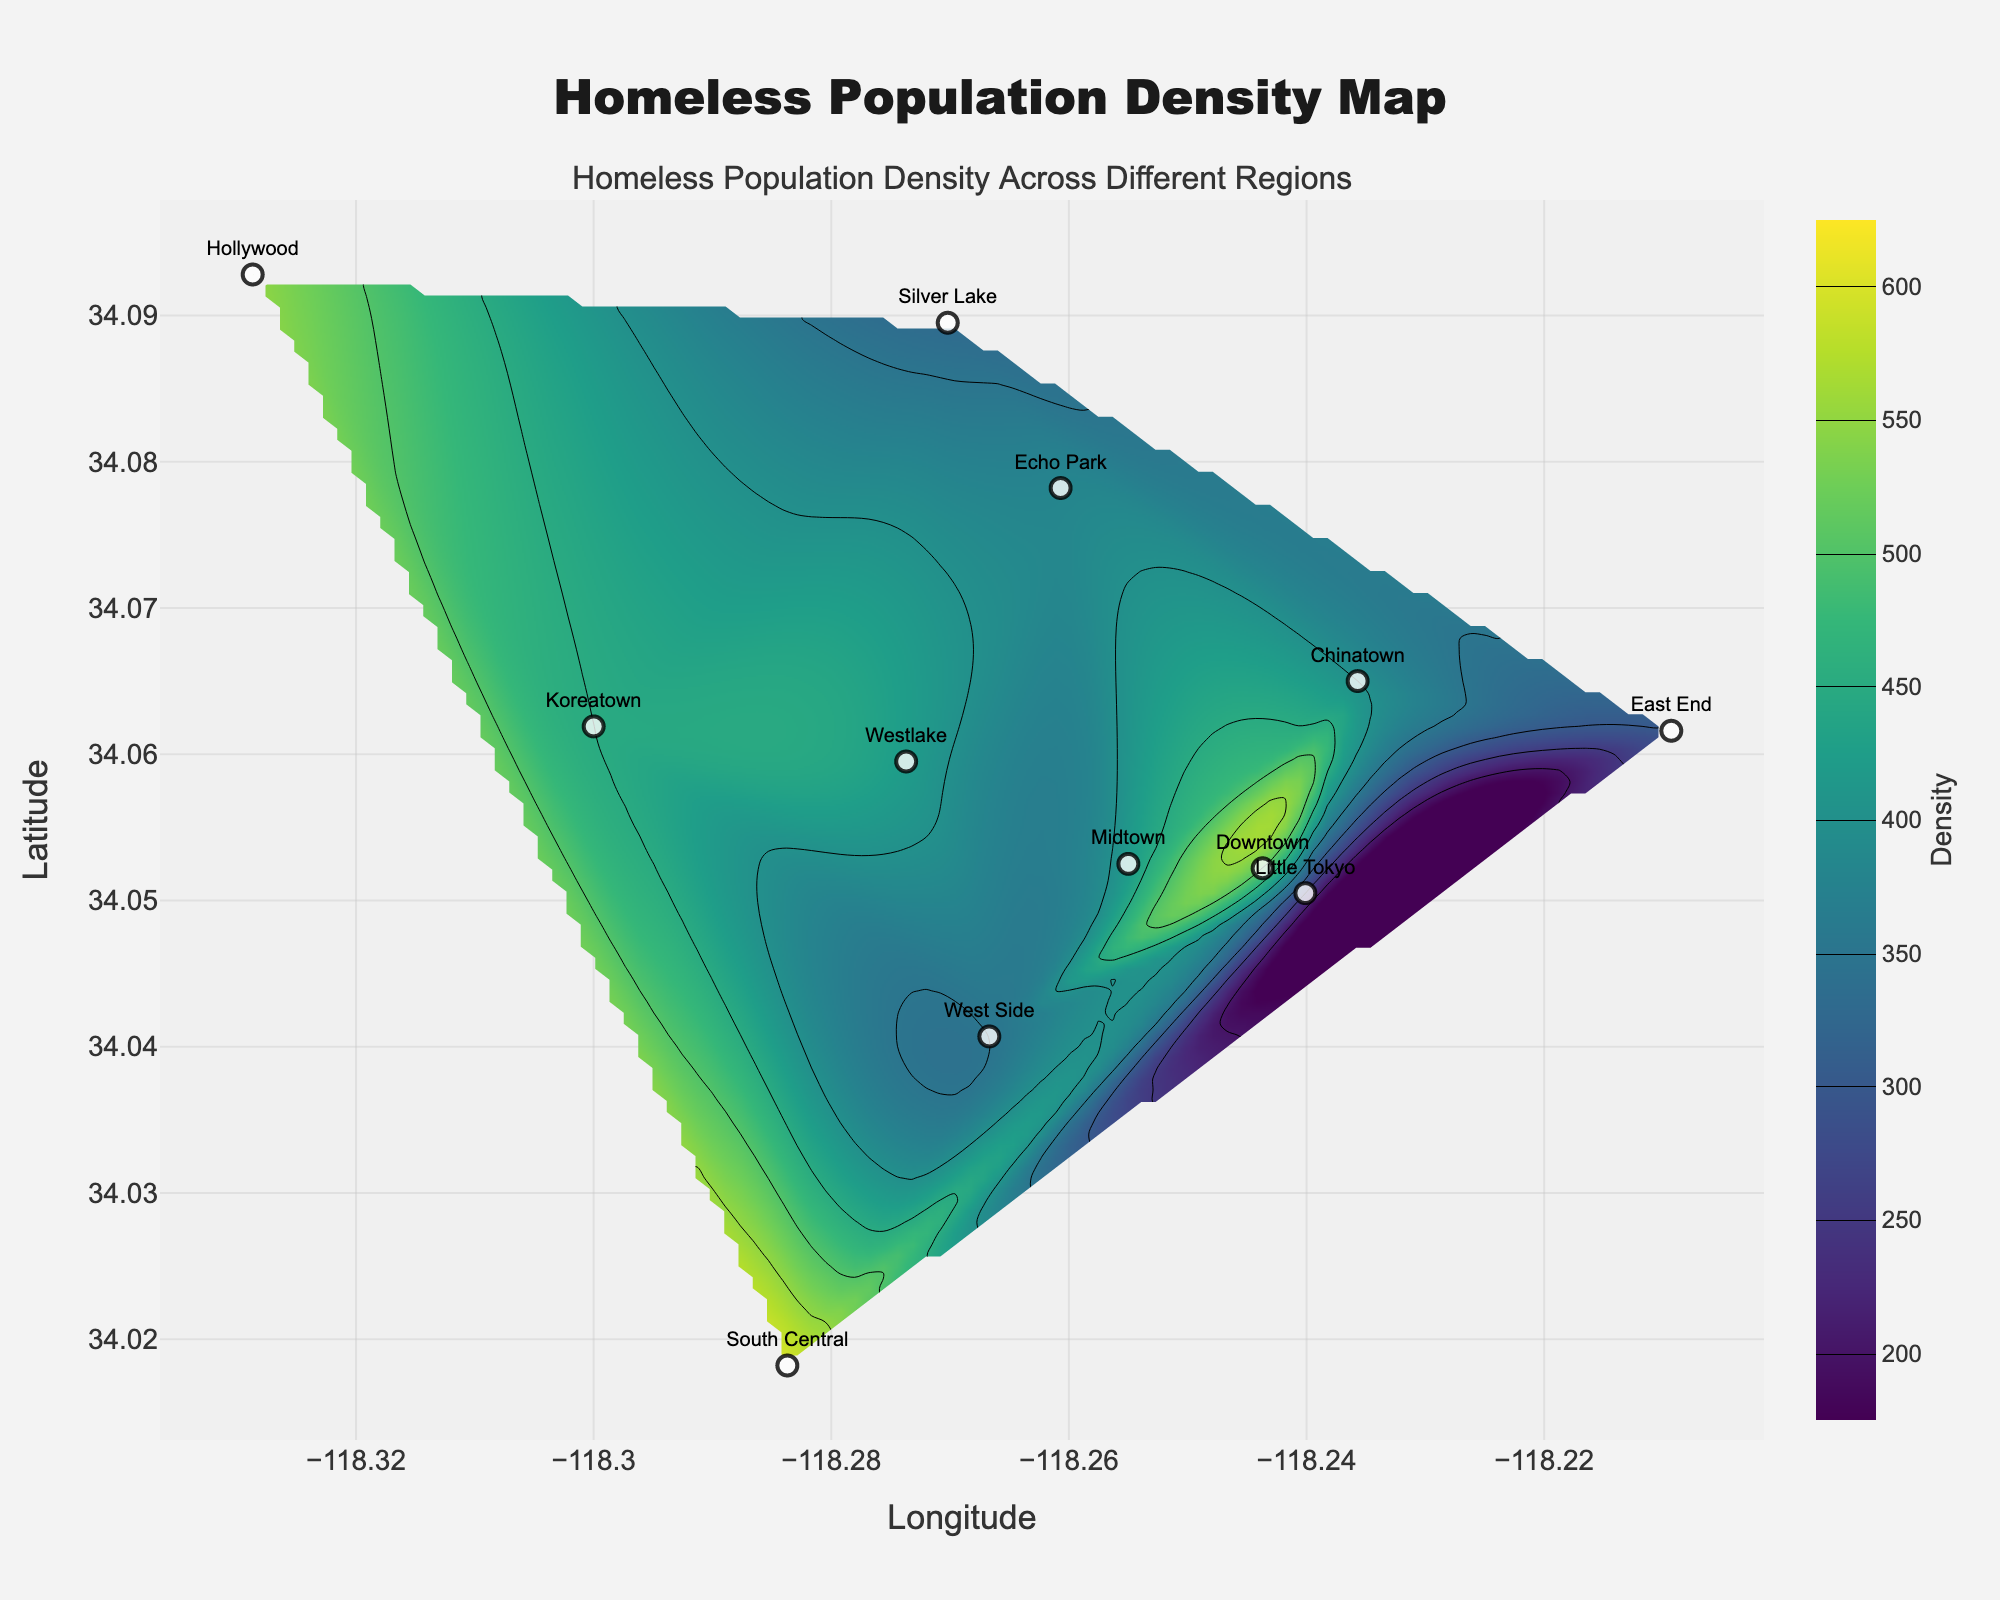What is the maximum homeless population density depicted on the contour map? To find this, observe the color bar that indicates density values. The darkest region on the contour map corresponds to the maximum density value depicted in the color bar, which is 600.
Answer: 600 Which region has the highest homeless population density? Look at the scatter plot labels on the contour map. South Central has the highest density, as indicated by its label and a value of 600.
Answer: South Central How do Downtown and Koreatown compare in terms of homeless population density? Locate the scatter data points for both Downtown and Koreatown on the plot. Downtown has a density value of 500, whereas Koreatown has 450. Downtown thus has a higher density than Koreatown by 50.
Answer: Downtown has a higher density Which regions are represented in the areas of lowest density based on the contour plot? The contour plot colors and the color bar guide us. The lighter regions on the plot have lower densities, mapped to values between 200-300. East End (300) and Little Tokyo (250) fall into this range.
Answer: East End and Little Tokyo What homeless population density value does the color green represent on the contour plot? Review the color bar to match the green color. The green color corresponds to a population density value of approximately 350 to 400.
Answer: 350 to 400 What is the average population density of Chinatown, Midtown, Echo Park, and Westlake? Extract their respective densities: Chinatown (400), Midtown (420), Echo Park (380), and Westlake (420). Add them up and divide by 4: (400 + 420 + 380 + 420) / 4 = 1620 / 4 = 405.
Answer: 405 What region is directly south of Hollywood on the contour plot? Identify Hollywood and look directly south in latitude positioning. This shows that Koreatown is directly south of Hollywood.
Answer: Koreatown Which areas on the map are identified as having a density above 450? Locate regions with densities greater than 450 on the contour map. These regions include South Central (600) and Hollywood (550), plus Downtown (500).
Answer: South Central, Hollywood, Downtown 